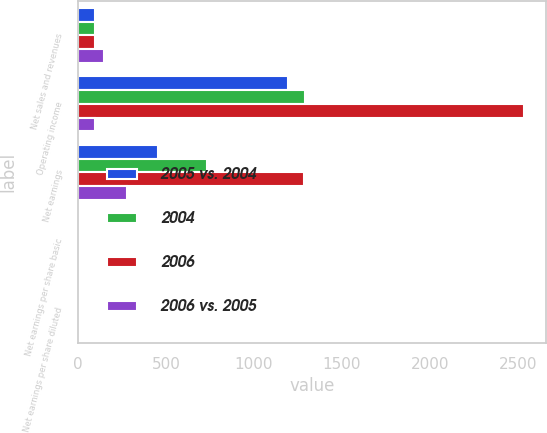Convert chart. <chart><loc_0><loc_0><loc_500><loc_500><stacked_bar_chart><ecel><fcel>Net sales and revenues<fcel>Operating income<fcel>Net earnings<fcel>Net earnings per share basic<fcel>Net earnings per share diluted<nl><fcel>2005 vs. 2004<fcel>98<fcel>1192<fcel>453<fcel>1.85<fcel>1.84<nl><fcel>2004<fcel>98<fcel>1290<fcel>733<fcel>3<fcel>2.98<nl><fcel>2006<fcel>98<fcel>2532<fcel>1283<fcel>5.45<fcel>5.43<nl><fcel>2006 vs. 2005<fcel>150<fcel>98<fcel>280<fcel>1.15<fcel>1.14<nl></chart> 